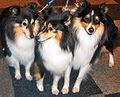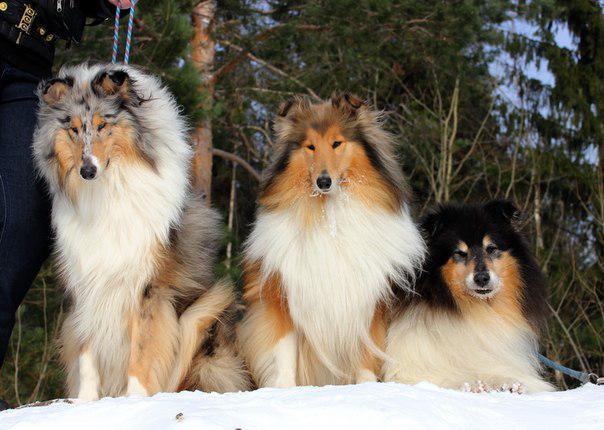The first image is the image on the left, the second image is the image on the right. Considering the images on both sides, is "Three collies pose together in both of the pictures." valid? Answer yes or no. Yes. The first image is the image on the left, the second image is the image on the right. For the images displayed, is the sentence "Each image contains exactly three dogs." factually correct? Answer yes or no. Yes. 